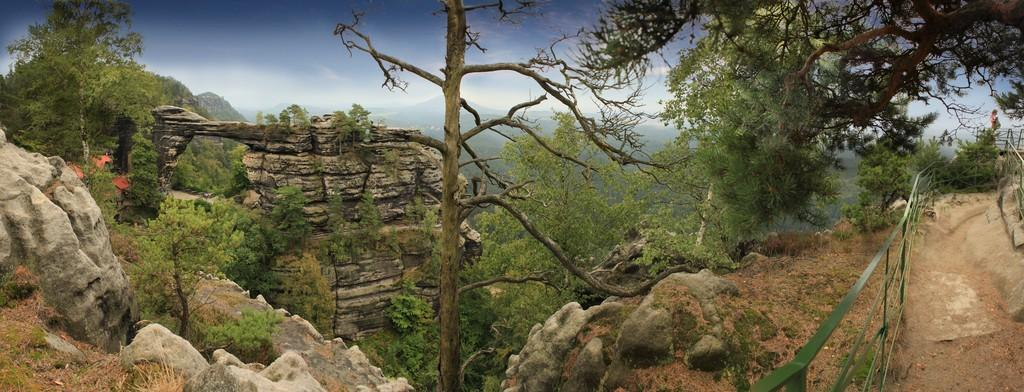What type of geological formation can be seen in the image? There are rock hills in the image. What structure is present in the image? There is a fence in the image. Can you describe the person in the image? There is a person standing in the image. What type of vegetation is present in the image? There are trees in the image. How would you describe the sky in the image? The sky is blue with clouds in the background. What type of wax is being used for the operation in the image? There is no operation or wax present in the image. What type of war is depicted in the image? There is no war depicted in the image; it features rock hills, a fence, a person, trees, and a blue sky with clouds. 